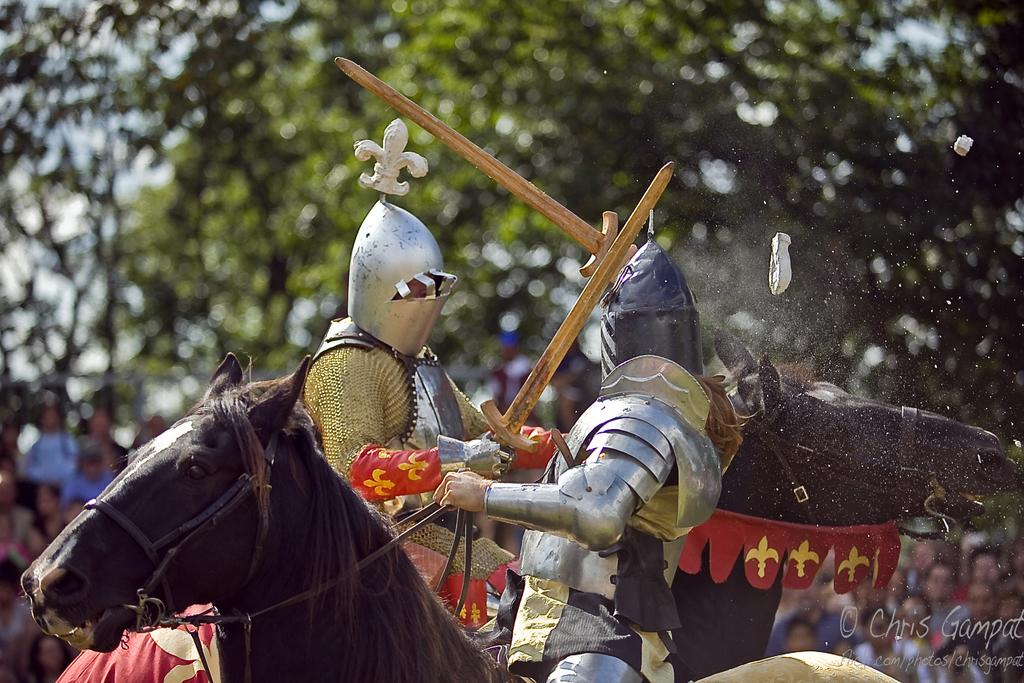How many people are in the image? There are two persons in the image. What are the persons wearing? The persons are wearing costumes. What objects are the persons holding? The persons are holding wooden knives. What are the persons sitting on? The persons are sitting on horses. What can be seen in the background of the image? There are people, trees, and the sky visible in the background of the image. What type of market can be seen in the image? There is no market present in the image; it features two persons in costumes, holding wooden knives, and sitting on horses. What is the desire of the persons in the image? There is no indication of the persons' desires in the image, as it only shows their appearance and actions. 